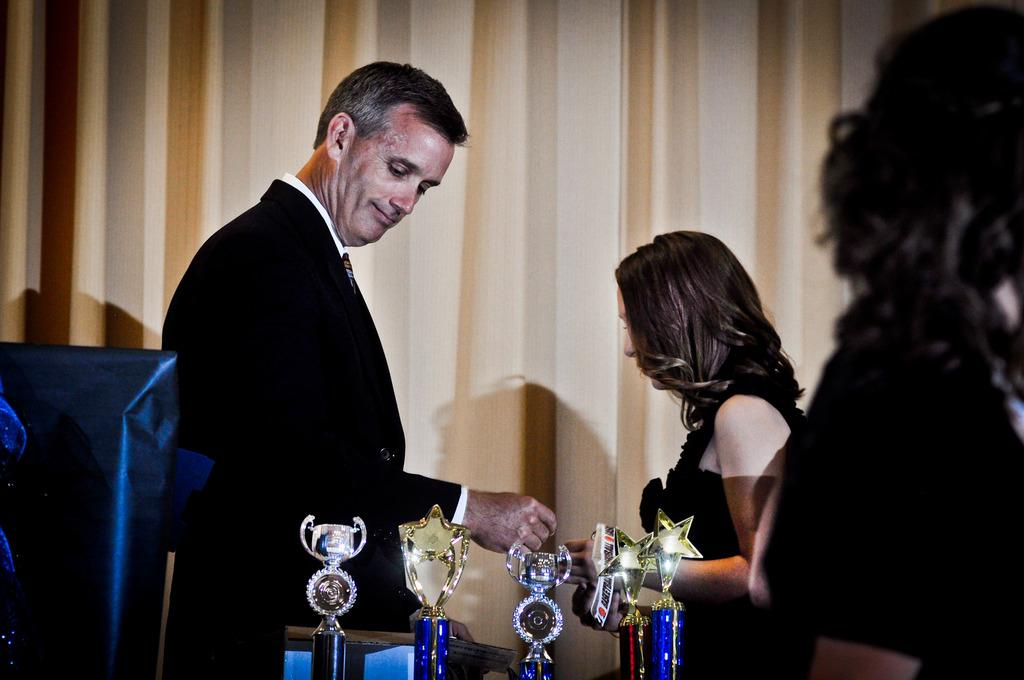Who are the two people standing in the center of the image? There is a man and a lady standing in the center of the image. What is located at the bottom of the image? There are awards at the bottom of the image. Can you describe the person on the right side of the image? There is a person on the right side of the image. What can be seen in the background of the image? There is a curtain visible in the background of the image. What type of key is the cook using to open the seat in the image? There is no cook, key, or seat present in the image. 